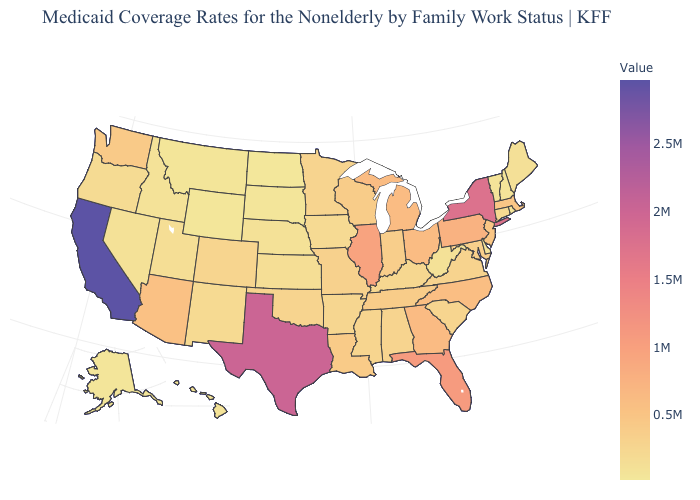Is the legend a continuous bar?
Keep it brief. Yes. Does Illinois have the highest value in the MidWest?
Short answer required. Yes. Does Vermont have the highest value in the Northeast?
Quick response, please. No. Is the legend a continuous bar?
Keep it brief. Yes. Does Illinois have the highest value in the MidWest?
Give a very brief answer. Yes. Which states have the highest value in the USA?
Short answer required. California. Does Illinois have the highest value in the MidWest?
Quick response, please. Yes. Which states have the lowest value in the West?
Short answer required. Wyoming. 